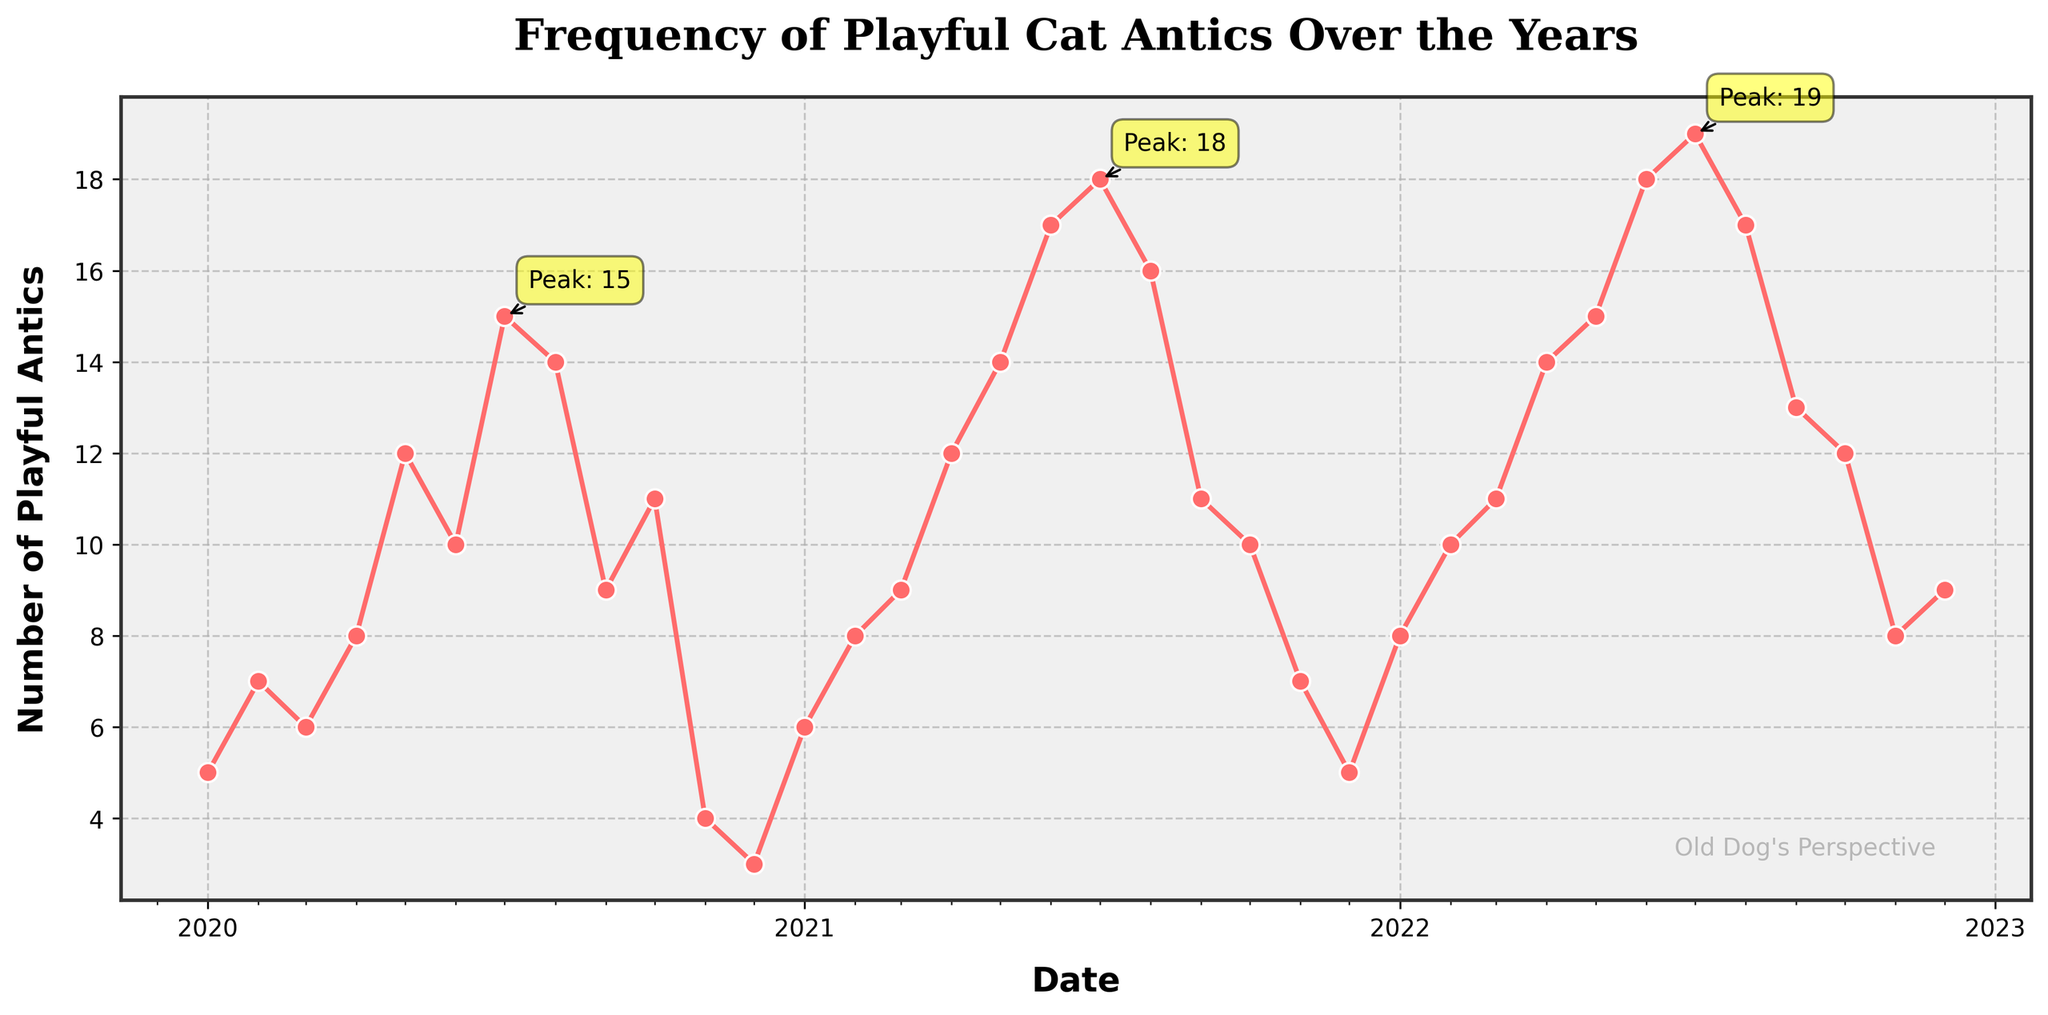What's the title of the plot? The title can be found at the top of the plot. It provides a quick overview of what the data represents.
Answer: Frequency of Playful Cat Antics Over the Years How many data points are there in the plot? Count the number of markers or data points plotted on the time series. Each marker represents a monthly data point over the three-year period from 2020 to 2022.
Answer: 36 What is the period with the highest frequency of playful cat antics? Identify the point on the plot where the data reaches its maximum value. This is where the highest number of playful antics is recorded.
Answer: July 2022 Is there a noticeable seasonal pattern in the frequency of playful cat antics? Look at the recurring peaks and troughs in the plot over the years. Patterns across the same months each year indicate seasonality.
Answer: Yes Which month consistently has lower frequency of playful cat antics according to the plot? Compare the frequency values for each month across different years to identify any months that repeatedly show lower values.
Answer: December How does the frequency of playful cat antics in January 2022 compare to January 2020? Locate the data points for January 2022 and January 2020 on the plot, and compare their values to see how they differ.
Answer: Higher In which year did the month of May have the highest frequency of playful cat antics? Look at the data points for May in each year (2020, 2021, 2022) and compare their values to determine the year with the highest frequency.
Answer: 2022 What is the general trend of playful cat antics frequency from January to December for each year? Observe the overall direction of the data points from January to December for each year. Check if the trend is increasing, decreasing, or fluctuating.
Answer: Fluctuating Are there more playful cat antics in the summer months (June to August) compared to the winter months (December to February)? Compare the average frequencies for the summer months and the winter months across the years. Sum up the frequencies for each period and calculate the averages.
Answer: Yes 